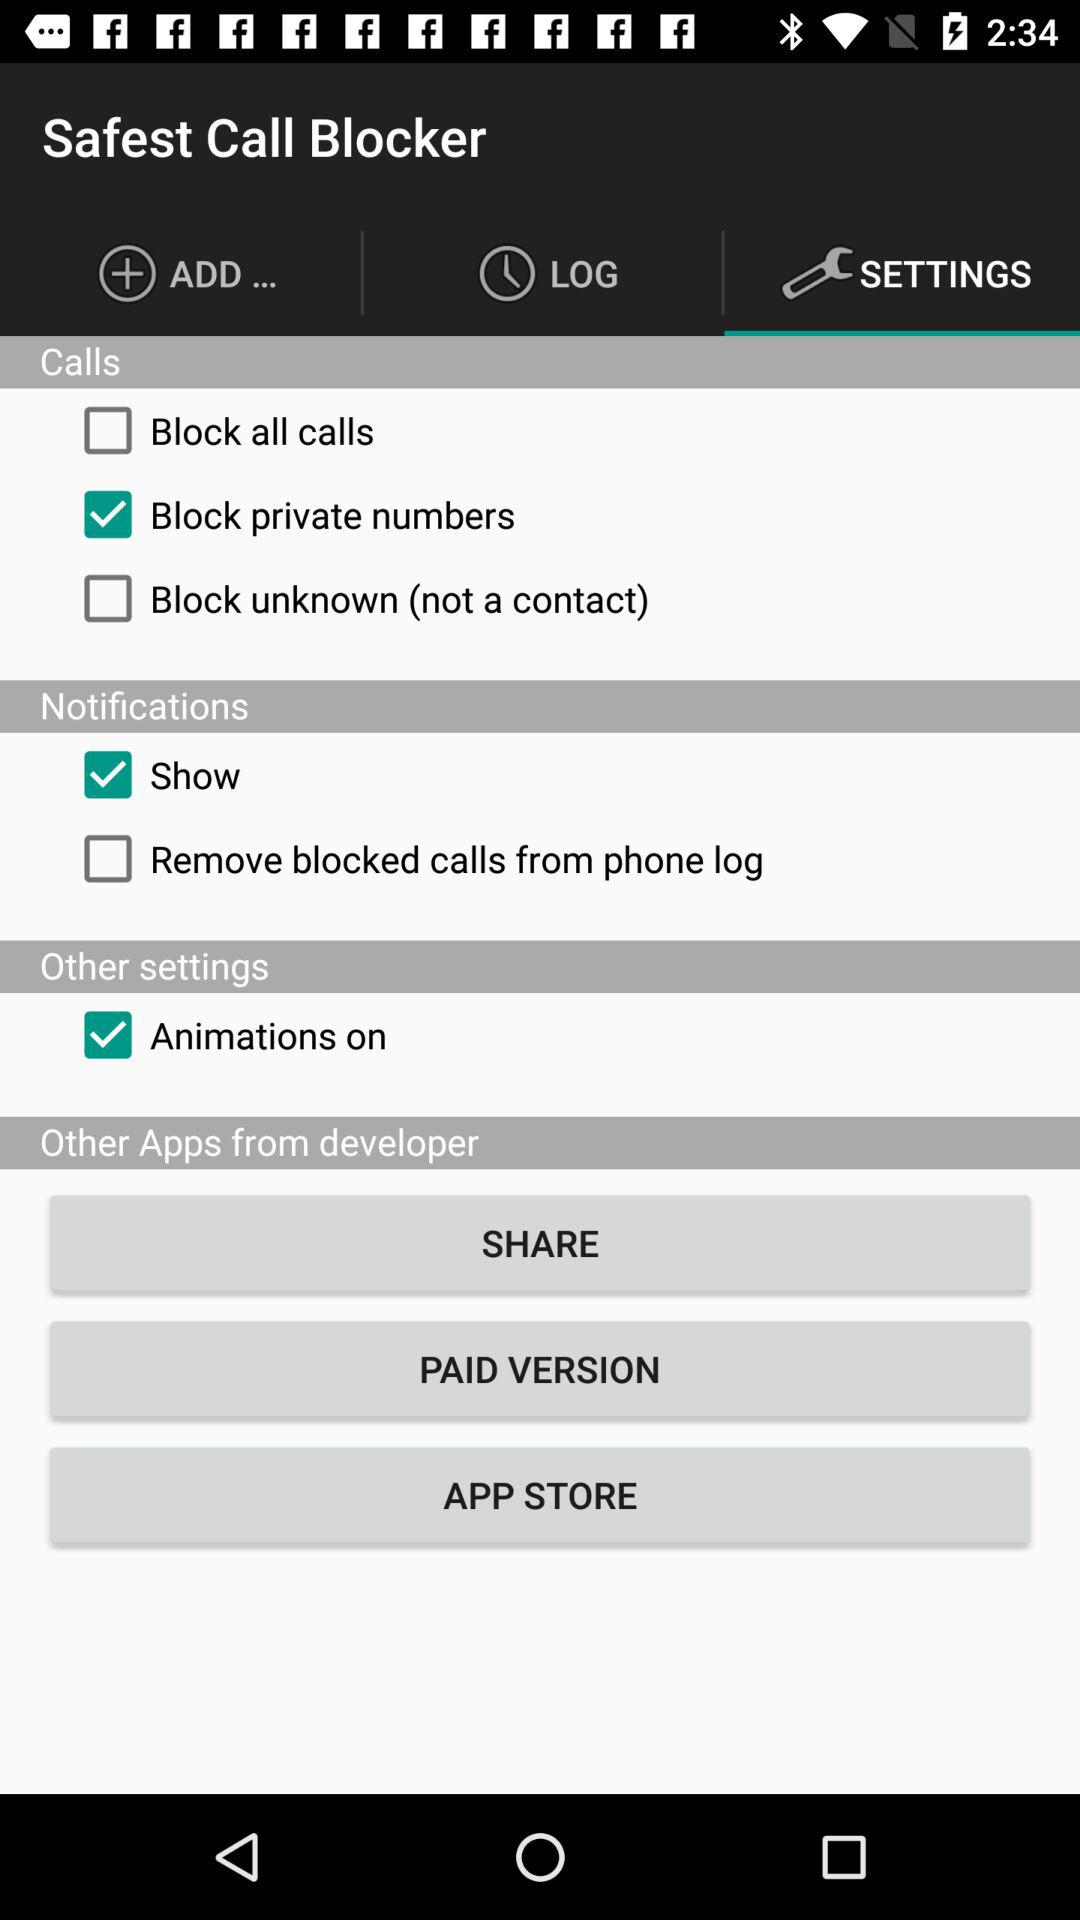How many checkboxes are there for blocking calls?
Answer the question using a single word or phrase. 3 